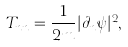Convert formula to latex. <formula><loc_0><loc_0><loc_500><loc_500>T _ { n n } = \frac { 1 } { 2 m } | \partial _ { n } \psi | ^ { 2 } ,</formula> 